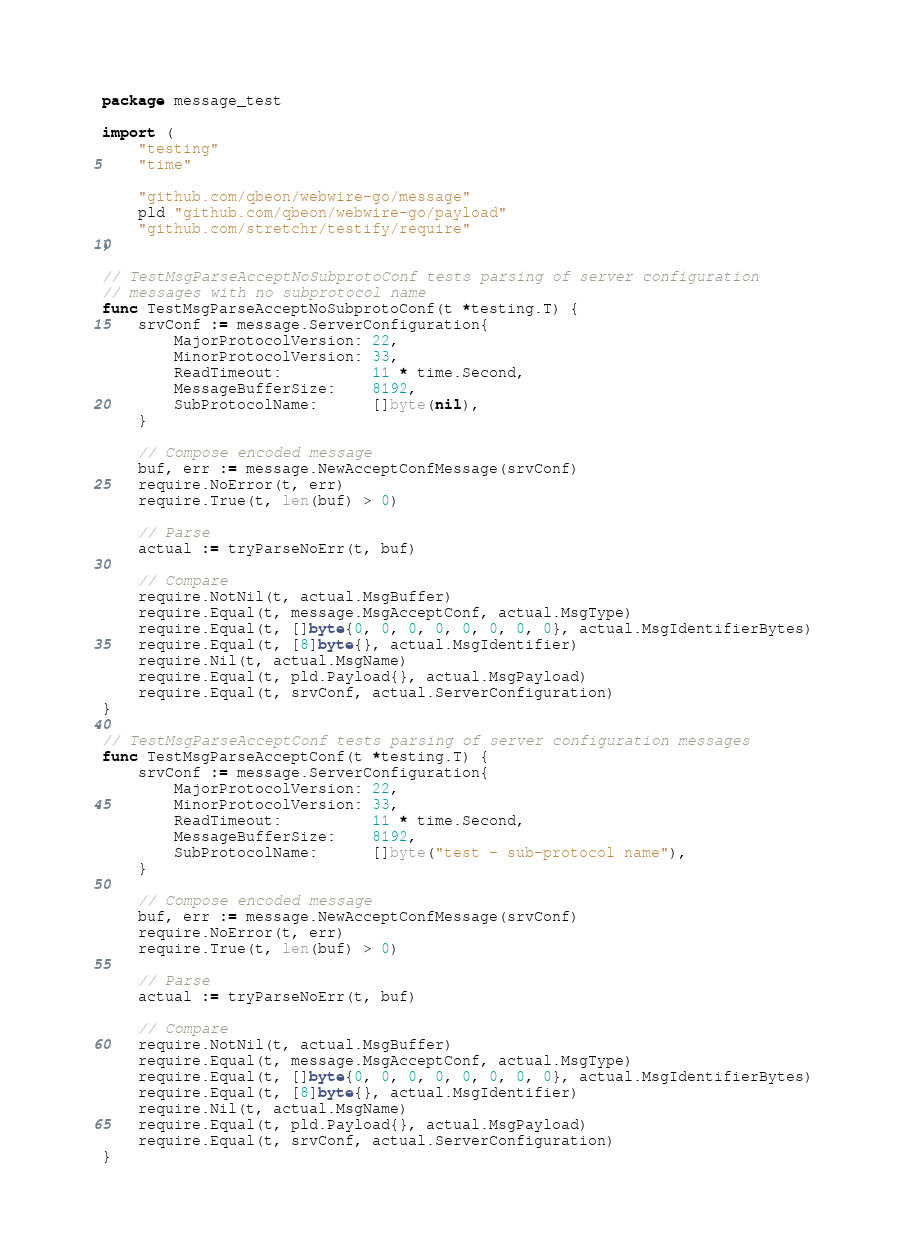<code> <loc_0><loc_0><loc_500><loc_500><_Go_>package message_test

import (
	"testing"
	"time"

	"github.com/qbeon/webwire-go/message"
	pld "github.com/qbeon/webwire-go/payload"
	"github.com/stretchr/testify/require"
)

// TestMsgParseAcceptNoSubprotoConf tests parsing of server configuration
// messages with no subprotocol name
func TestMsgParseAcceptNoSubprotoConf(t *testing.T) {
	srvConf := message.ServerConfiguration{
		MajorProtocolVersion: 22,
		MinorProtocolVersion: 33,
		ReadTimeout:          11 * time.Second,
		MessageBufferSize:    8192,
		SubProtocolName:      []byte(nil),
	}

	// Compose encoded message
	buf, err := message.NewAcceptConfMessage(srvConf)
	require.NoError(t, err)
	require.True(t, len(buf) > 0)

	// Parse
	actual := tryParseNoErr(t, buf)

	// Compare
	require.NotNil(t, actual.MsgBuffer)
	require.Equal(t, message.MsgAcceptConf, actual.MsgType)
	require.Equal(t, []byte{0, 0, 0, 0, 0, 0, 0, 0}, actual.MsgIdentifierBytes)
	require.Equal(t, [8]byte{}, actual.MsgIdentifier)
	require.Nil(t, actual.MsgName)
	require.Equal(t, pld.Payload{}, actual.MsgPayload)
	require.Equal(t, srvConf, actual.ServerConfiguration)
}

// TestMsgParseAcceptConf tests parsing of server configuration messages
func TestMsgParseAcceptConf(t *testing.T) {
	srvConf := message.ServerConfiguration{
		MajorProtocolVersion: 22,
		MinorProtocolVersion: 33,
		ReadTimeout:          11 * time.Second,
		MessageBufferSize:    8192,
		SubProtocolName:      []byte("test - sub-protocol name"),
	}

	// Compose encoded message
	buf, err := message.NewAcceptConfMessage(srvConf)
	require.NoError(t, err)
	require.True(t, len(buf) > 0)

	// Parse
	actual := tryParseNoErr(t, buf)

	// Compare
	require.NotNil(t, actual.MsgBuffer)
	require.Equal(t, message.MsgAcceptConf, actual.MsgType)
	require.Equal(t, []byte{0, 0, 0, 0, 0, 0, 0, 0}, actual.MsgIdentifierBytes)
	require.Equal(t, [8]byte{}, actual.MsgIdentifier)
	require.Nil(t, actual.MsgName)
	require.Equal(t, pld.Payload{}, actual.MsgPayload)
	require.Equal(t, srvConf, actual.ServerConfiguration)
}
</code> 